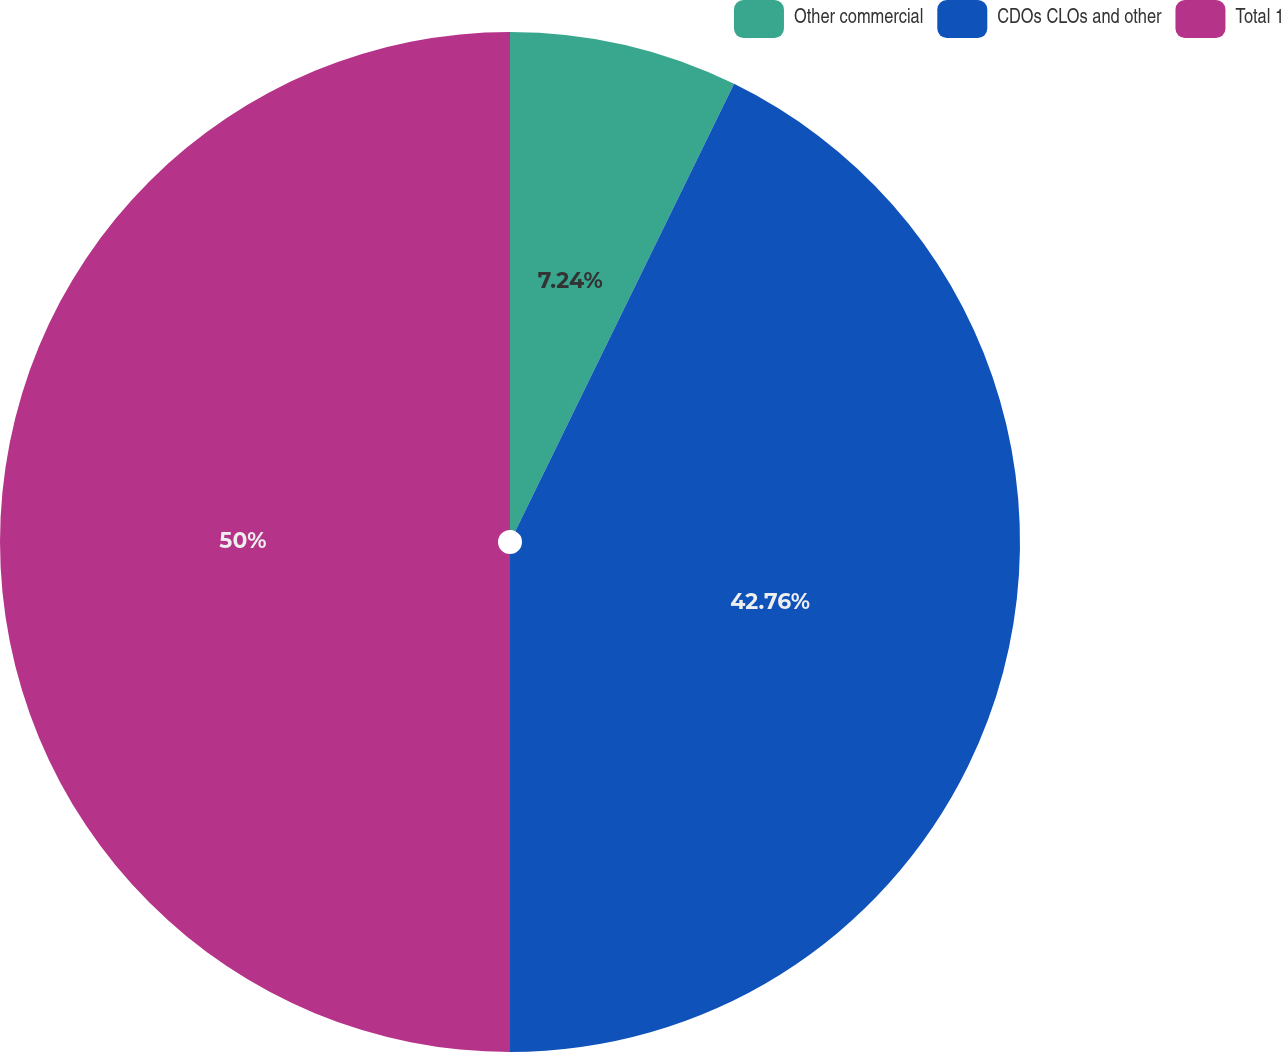Convert chart. <chart><loc_0><loc_0><loc_500><loc_500><pie_chart><fcel>Other commercial<fcel>CDOs CLOs and other<fcel>Total 1<nl><fcel>7.24%<fcel>42.76%<fcel>50.0%<nl></chart> 